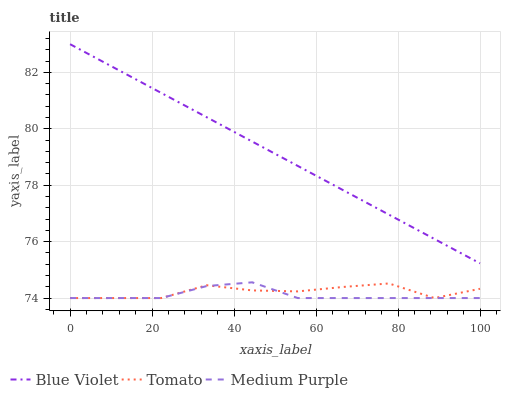Does Medium Purple have the minimum area under the curve?
Answer yes or no. Yes. Does Blue Violet have the maximum area under the curve?
Answer yes or no. Yes. Does Blue Violet have the minimum area under the curve?
Answer yes or no. No. Does Medium Purple have the maximum area under the curve?
Answer yes or no. No. Is Blue Violet the smoothest?
Answer yes or no. Yes. Is Tomato the roughest?
Answer yes or no. Yes. Is Medium Purple the smoothest?
Answer yes or no. No. Is Medium Purple the roughest?
Answer yes or no. No. Does Tomato have the lowest value?
Answer yes or no. Yes. Does Blue Violet have the lowest value?
Answer yes or no. No. Does Blue Violet have the highest value?
Answer yes or no. Yes. Does Medium Purple have the highest value?
Answer yes or no. No. Is Tomato less than Blue Violet?
Answer yes or no. Yes. Is Blue Violet greater than Tomato?
Answer yes or no. Yes. Does Medium Purple intersect Tomato?
Answer yes or no. Yes. Is Medium Purple less than Tomato?
Answer yes or no. No. Is Medium Purple greater than Tomato?
Answer yes or no. No. Does Tomato intersect Blue Violet?
Answer yes or no. No. 